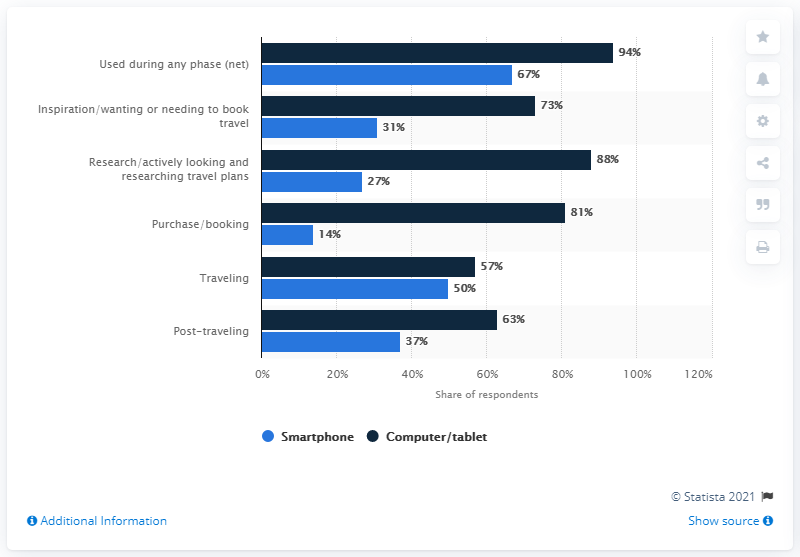Draw attention to some important aspects in this diagram. In the process of purchasing or booking, 14% of people use a smartphone, while the remaining 81% use a computer or tablet. In traveling, if 50% of smartphones are equal to 1000, then 57% of computers and tablets would be equal to 1140. 